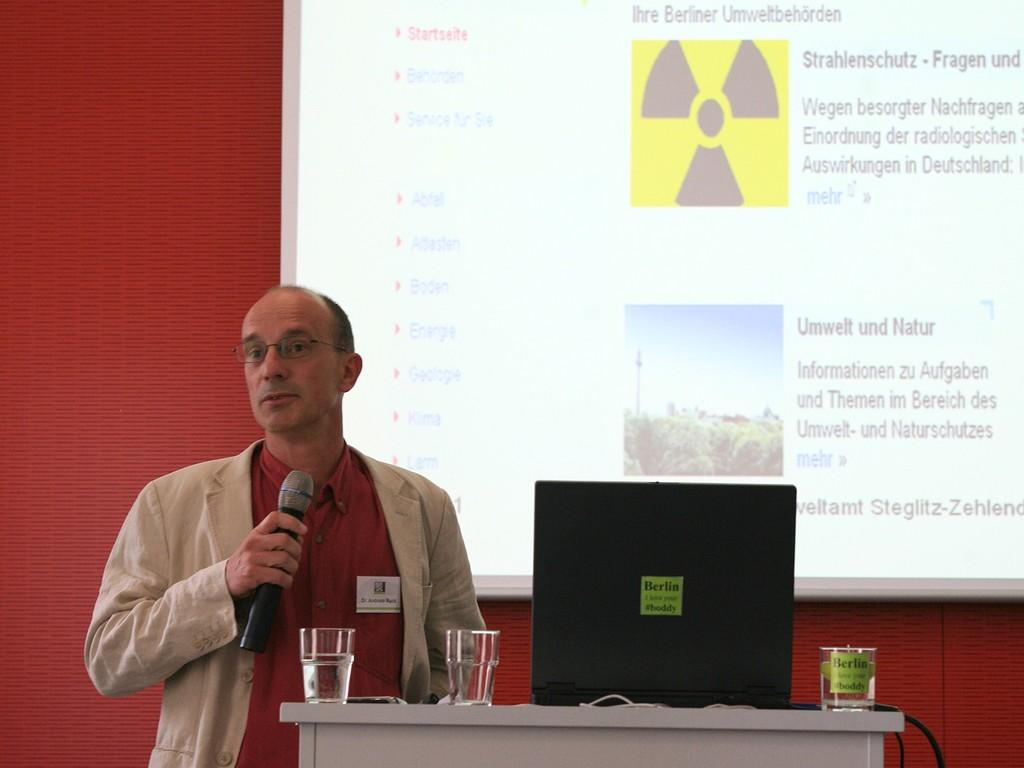What is the person in the image holding? The person is holding a microphone in the image. What object is typically used for public speaking or presentations? There is a podium in the image, which is often used for public speaking or presentations. What can be seen on the table or surface in the image? There are glasses visible in the image. What information is displayed on the screen in the image? There is a screen with text in the image. What type of device might be used for displaying information or playing media? An electronic gadget is present in the image. Where is the beggar sitting in the image? There is no beggar present in the image. What is the highest point in the image? The image does not depict a specific location or elevation, so it is not possible to determine the highest point. 